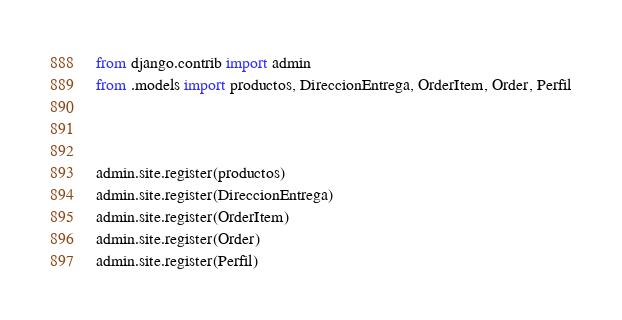<code> <loc_0><loc_0><loc_500><loc_500><_Python_>from django.contrib import admin
from .models import productos, DireccionEntrega, OrderItem, Order, Perfil



admin.site.register(productos)
admin.site.register(DireccionEntrega)
admin.site.register(OrderItem)
admin.site.register(Order)
admin.site.register(Perfil)

</code> 